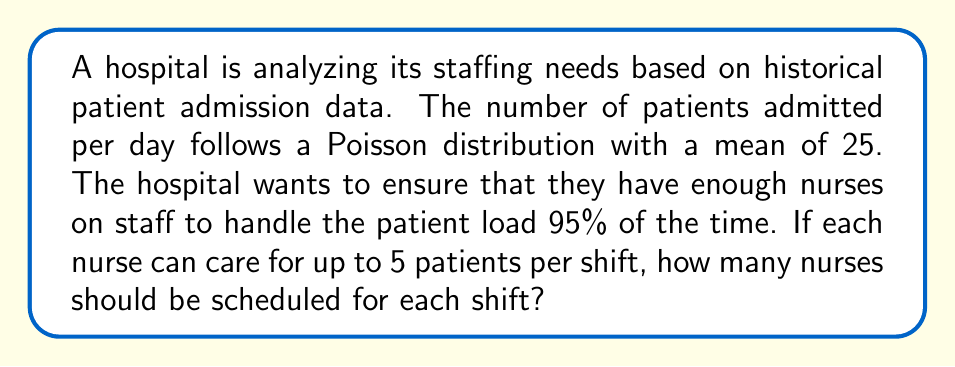Provide a solution to this math problem. To solve this problem, we'll use the Poisson distribution and its cumulative distribution function (CDF). We need to find the number of patients that will cover 95% of all possible scenarios, then determine how many nurses are needed to care for that many patients.

1. Let $X$ be the number of patients admitted per day. We know that $X \sim \text{Poisson}(\lambda = 25)$.

2. We need to find the value $k$ such that $P(X \leq k) \geq 0.95$.

3. The CDF of a Poisson distribution is given by:

   $$F(k; \lambda) = P(X \leq k) = e^{-\lambda} \sum_{i=0}^k \frac{\lambda^i}{i!}$$

4. We can use software or tables to find the smallest $k$ that satisfies this condition. In this case, $k = 34$.

5. This means that 95% of the time, there will be 34 or fewer patients admitted.

6. To determine the number of nurses needed, we divide the number of patients by the number of patients each nurse can care for:

   $$\text{Number of nurses} = \left\lceil\frac{34 \text{ patients}}{5 \text{ patients per nurse}}\right\rceil = \left\lceil6.8\right\rceil = 7$$

   We round up to ensure we have enough nurses to cover all patients.

Therefore, the hospital should schedule 7 nurses per shift to handle the patient load 95% of the time.
Answer: 7 nurses 